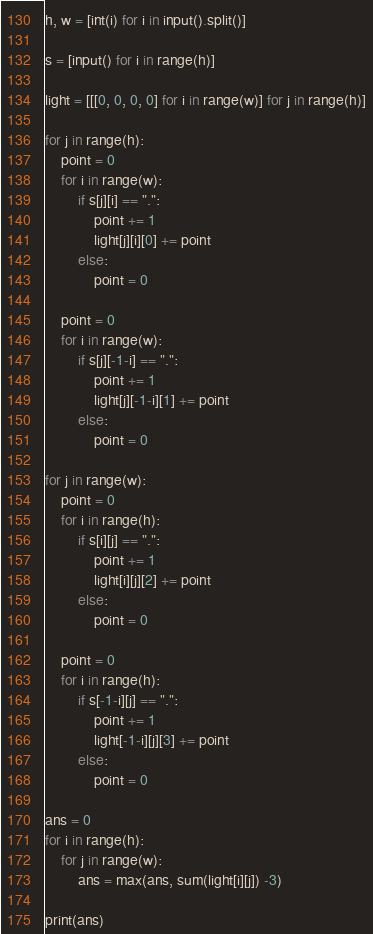Convert code to text. <code><loc_0><loc_0><loc_500><loc_500><_Python_>h, w = [int(i) for i in input().split()]

s = [input() for i in range(h)]

light = [[[0, 0, 0, 0] for i in range(w)] for j in range(h)]

for j in range(h):
    point = 0
    for i in range(w):
        if s[j][i] == ".":
            point += 1
            light[j][i][0] += point
        else:
            point = 0

    point = 0
    for i in range(w):
        if s[j][-1-i] == ".":
            point += 1
            light[j][-1-i][1] += point
        else:
            point = 0

for j in range(w):
    point = 0
    for i in range(h):
        if s[i][j] == ".":
            point += 1
            light[i][j][2] += point
        else:
            point = 0

    point = 0
    for i in range(h):
        if s[-1-i][j] == ".":
            point += 1
            light[-1-i][j][3] += point
        else:
            point = 0

ans = 0
for i in range(h):
    for j in range(w):
        ans = max(ans, sum(light[i][j]) -3)

print(ans)
</code> 